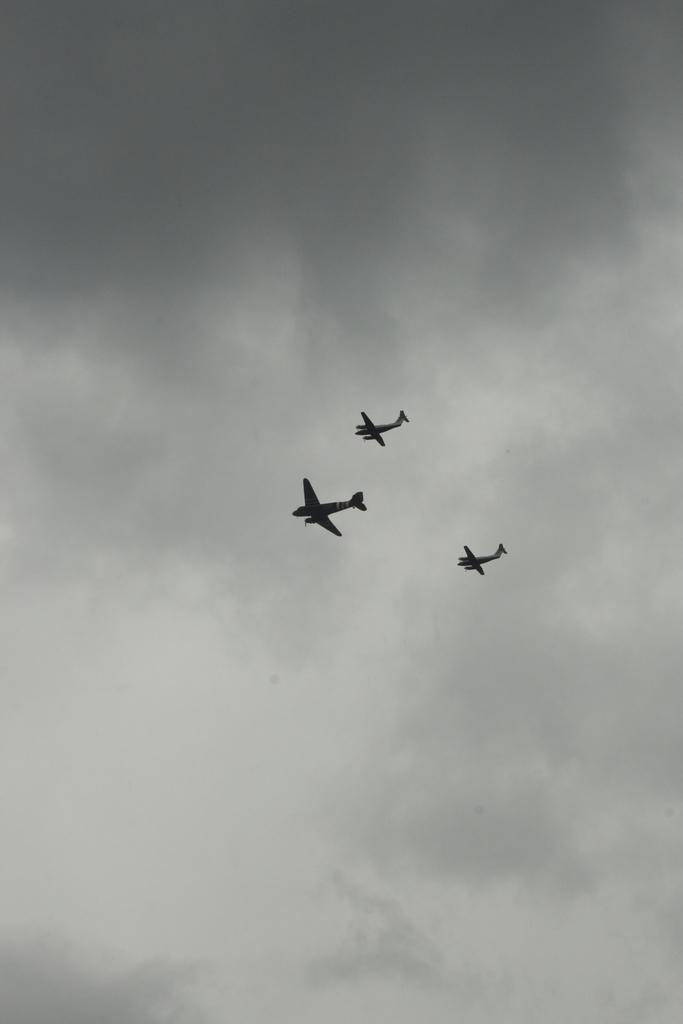Please provide a concise description of this image. In the center of the image we can see aeroplanes in the air. In the background we can see sky and clouds. 